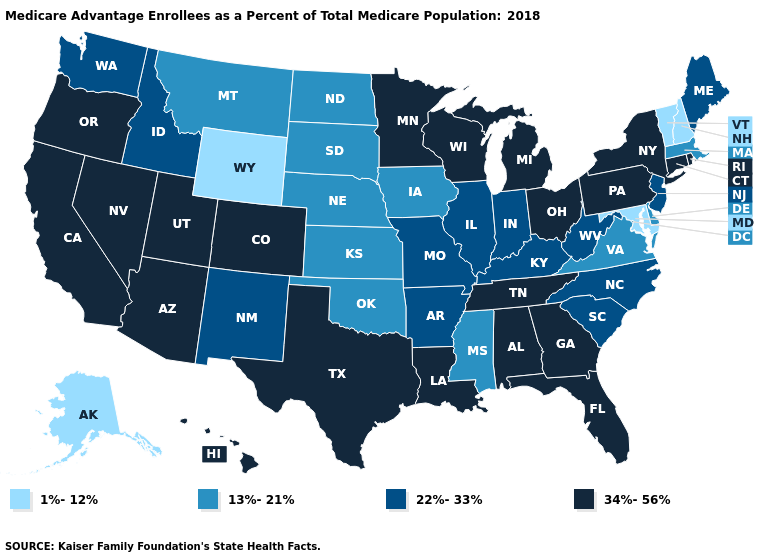What is the highest value in the USA?
Write a very short answer. 34%-56%. What is the value of Kansas?
Concise answer only. 13%-21%. Does Hawaii have the highest value in the USA?
Write a very short answer. Yes. What is the value of Oregon?
Write a very short answer. 34%-56%. Name the states that have a value in the range 1%-12%?
Short answer required. Alaska, Maryland, New Hampshire, Vermont, Wyoming. Which states have the lowest value in the Northeast?
Write a very short answer. New Hampshire, Vermont. What is the value of Nevada?
Answer briefly. 34%-56%. What is the highest value in states that border Colorado?
Short answer required. 34%-56%. Name the states that have a value in the range 34%-56%?
Answer briefly. Alabama, Arizona, California, Colorado, Connecticut, Florida, Georgia, Hawaii, Louisiana, Michigan, Minnesota, Nevada, New York, Ohio, Oregon, Pennsylvania, Rhode Island, Tennessee, Texas, Utah, Wisconsin. What is the lowest value in states that border Indiana?
Concise answer only. 22%-33%. Name the states that have a value in the range 1%-12%?
Be succinct. Alaska, Maryland, New Hampshire, Vermont, Wyoming. Name the states that have a value in the range 13%-21%?
Short answer required. Delaware, Iowa, Kansas, Massachusetts, Mississippi, Montana, Nebraska, North Dakota, Oklahoma, South Dakota, Virginia. Is the legend a continuous bar?
Be succinct. No. What is the value of Connecticut?
Answer briefly. 34%-56%. Does the first symbol in the legend represent the smallest category?
Be succinct. Yes. 